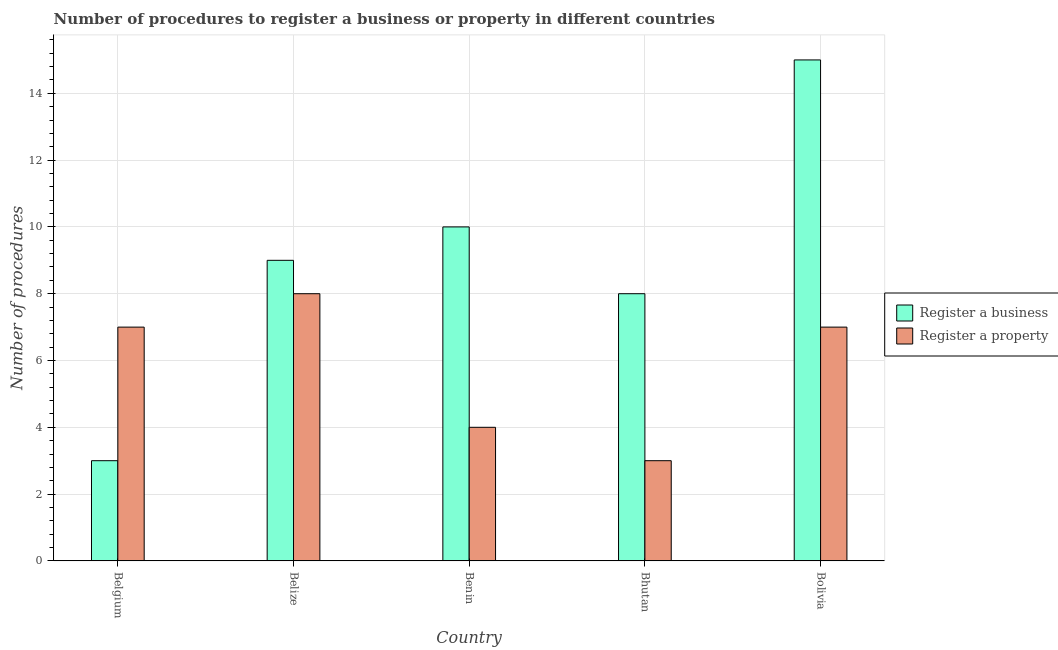Are the number of bars on each tick of the X-axis equal?
Give a very brief answer. Yes. How many bars are there on the 5th tick from the right?
Your response must be concise. 2. What is the label of the 3rd group of bars from the left?
Your answer should be compact. Benin. What is the number of procedures to register a property in Bhutan?
Offer a very short reply. 3. Across all countries, what is the maximum number of procedures to register a business?
Your response must be concise. 15. Across all countries, what is the minimum number of procedures to register a property?
Ensure brevity in your answer.  3. In which country was the number of procedures to register a property minimum?
Give a very brief answer. Bhutan. What is the difference between the number of procedures to register a property in Belgium and that in Bolivia?
Make the answer very short. 0. What is the difference between the number of procedures to register a property and number of procedures to register a business in Bhutan?
Give a very brief answer. -5. What is the ratio of the number of procedures to register a business in Belgium to that in Benin?
Provide a short and direct response. 0.3. What is the difference between the highest and the second highest number of procedures to register a business?
Offer a terse response. 5. What is the difference between the highest and the lowest number of procedures to register a property?
Your answer should be very brief. 5. Is the sum of the number of procedures to register a business in Belgium and Bhutan greater than the maximum number of procedures to register a property across all countries?
Your answer should be compact. Yes. What does the 1st bar from the left in Benin represents?
Ensure brevity in your answer.  Register a business. What does the 2nd bar from the right in Belize represents?
Give a very brief answer. Register a business. How many bars are there?
Give a very brief answer. 10. What is the difference between two consecutive major ticks on the Y-axis?
Make the answer very short. 2. Does the graph contain any zero values?
Ensure brevity in your answer.  No. Does the graph contain grids?
Provide a short and direct response. Yes. How are the legend labels stacked?
Provide a succinct answer. Vertical. What is the title of the graph?
Provide a short and direct response. Number of procedures to register a business or property in different countries. What is the label or title of the X-axis?
Offer a very short reply. Country. What is the label or title of the Y-axis?
Keep it short and to the point. Number of procedures. What is the Number of procedures of Register a business in Belgium?
Make the answer very short. 3. What is the Number of procedures of Register a property in Belgium?
Your answer should be very brief. 7. What is the Number of procedures in Register a property in Benin?
Give a very brief answer. 4. What is the Number of procedures of Register a property in Bhutan?
Ensure brevity in your answer.  3. Across all countries, what is the maximum Number of procedures of Register a property?
Provide a short and direct response. 8. Across all countries, what is the minimum Number of procedures in Register a property?
Ensure brevity in your answer.  3. What is the total Number of procedures in Register a business in the graph?
Your response must be concise. 45. What is the total Number of procedures in Register a property in the graph?
Your response must be concise. 29. What is the difference between the Number of procedures in Register a business in Belgium and that in Belize?
Keep it short and to the point. -6. What is the difference between the Number of procedures in Register a property in Belgium and that in Belize?
Keep it short and to the point. -1. What is the difference between the Number of procedures of Register a business in Belgium and that in Benin?
Offer a terse response. -7. What is the difference between the Number of procedures in Register a property in Belgium and that in Bolivia?
Ensure brevity in your answer.  0. What is the difference between the Number of procedures in Register a business in Belize and that in Benin?
Your response must be concise. -1. What is the difference between the Number of procedures of Register a property in Belize and that in Bhutan?
Your answer should be compact. 5. What is the difference between the Number of procedures of Register a business in Benin and that in Bhutan?
Offer a terse response. 2. What is the difference between the Number of procedures of Register a property in Benin and that in Bhutan?
Give a very brief answer. 1. What is the difference between the Number of procedures in Register a business in Belize and the Number of procedures in Register a property in Bhutan?
Offer a very short reply. 6. What is the average Number of procedures in Register a property per country?
Give a very brief answer. 5.8. What is the ratio of the Number of procedures in Register a business in Belgium to that in Belize?
Offer a terse response. 0.33. What is the ratio of the Number of procedures of Register a business in Belgium to that in Benin?
Make the answer very short. 0.3. What is the ratio of the Number of procedures of Register a property in Belgium to that in Bhutan?
Give a very brief answer. 2.33. What is the ratio of the Number of procedures in Register a business in Belize to that in Benin?
Your answer should be very brief. 0.9. What is the ratio of the Number of procedures in Register a property in Belize to that in Benin?
Your response must be concise. 2. What is the ratio of the Number of procedures of Register a business in Belize to that in Bhutan?
Keep it short and to the point. 1.12. What is the ratio of the Number of procedures of Register a property in Belize to that in Bhutan?
Provide a short and direct response. 2.67. What is the ratio of the Number of procedures of Register a business in Belize to that in Bolivia?
Offer a terse response. 0.6. What is the ratio of the Number of procedures of Register a business in Benin to that in Bhutan?
Offer a terse response. 1.25. What is the ratio of the Number of procedures in Register a property in Benin to that in Bhutan?
Give a very brief answer. 1.33. What is the ratio of the Number of procedures of Register a property in Benin to that in Bolivia?
Provide a succinct answer. 0.57. What is the ratio of the Number of procedures in Register a business in Bhutan to that in Bolivia?
Your answer should be very brief. 0.53. What is the ratio of the Number of procedures of Register a property in Bhutan to that in Bolivia?
Ensure brevity in your answer.  0.43. What is the difference between the highest and the second highest Number of procedures in Register a property?
Offer a terse response. 1. What is the difference between the highest and the lowest Number of procedures of Register a business?
Your answer should be compact. 12. 